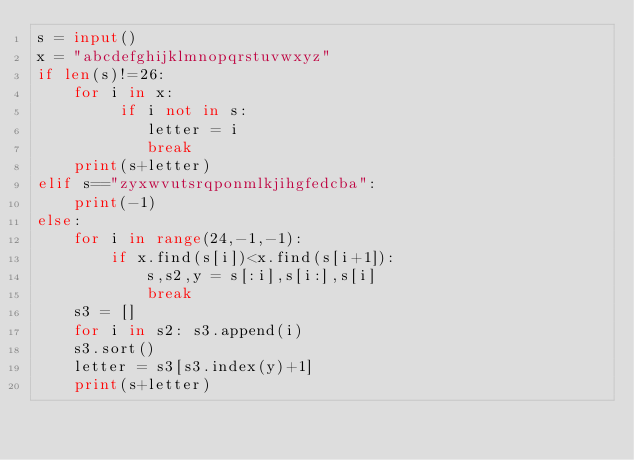<code> <loc_0><loc_0><loc_500><loc_500><_Python_>s = input()
x = "abcdefghijklmnopqrstuvwxyz"
if len(s)!=26:
	for i in x:
		 if i not in s:
		 	letter = i
		 	break
	print(s+letter)
elif s=="zyxwvutsrqponmlkjihgfedcba":
	print(-1)
else:
	for i in range(24,-1,-1):
		if x.find(s[i])<x.find(s[i+1]):
			s,s2,y = s[:i],s[i:],s[i]
			break
	s3 = []
	for i in s2: s3.append(i)
	s3.sort()
	letter = s3[s3.index(y)+1]
	print(s+letter)</code> 